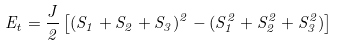<formula> <loc_0><loc_0><loc_500><loc_500>E _ { t } = \frac { J } { 2 } \left [ ( S _ { 1 } + S _ { 2 } + S _ { 3 } ) ^ { 2 } - ( S _ { 1 } ^ { 2 } + S _ { 2 } ^ { 2 } + S _ { 3 } ^ { 2 } ) \right ]</formula> 